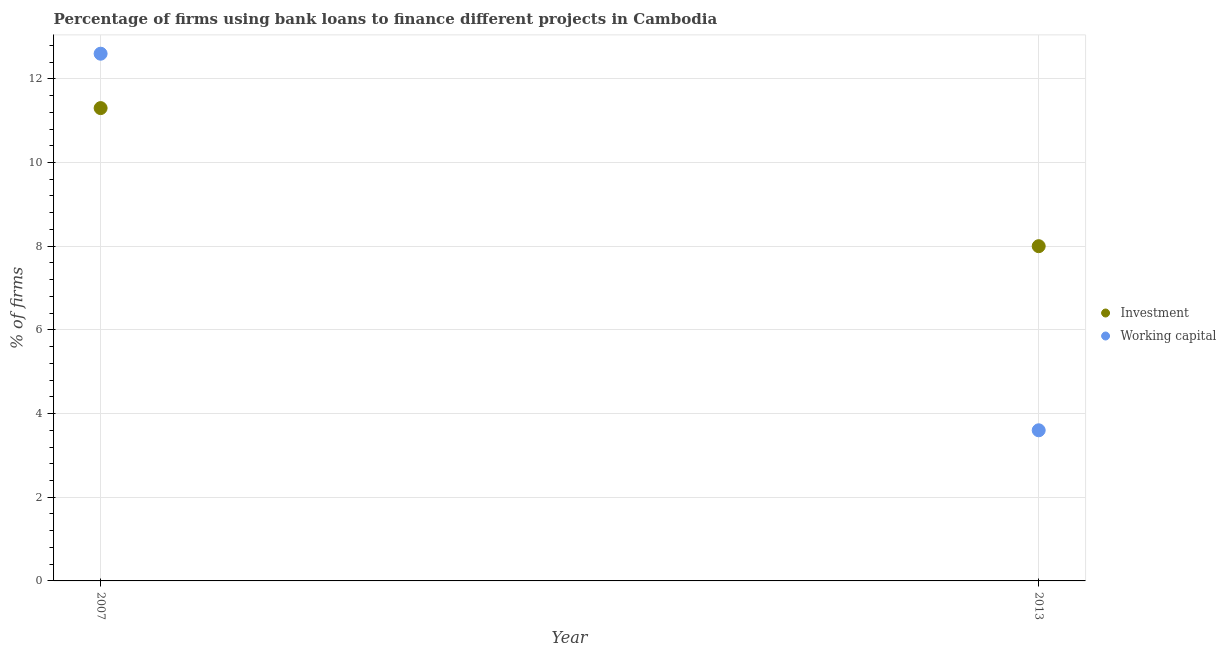How many different coloured dotlines are there?
Offer a terse response. 2. Is the number of dotlines equal to the number of legend labels?
Provide a succinct answer. Yes. In which year was the percentage of firms using banks to finance investment maximum?
Make the answer very short. 2007. What is the total percentage of firms using banks to finance working capital in the graph?
Offer a very short reply. 16.2. What is the difference between the percentage of firms using banks to finance investment in 2007 and that in 2013?
Give a very brief answer. 3.3. What is the difference between the percentage of firms using banks to finance investment in 2007 and the percentage of firms using banks to finance working capital in 2013?
Keep it short and to the point. 7.7. What is the average percentage of firms using banks to finance investment per year?
Keep it short and to the point. 9.65. In the year 2007, what is the difference between the percentage of firms using banks to finance working capital and percentage of firms using banks to finance investment?
Offer a very short reply. 1.3. What is the ratio of the percentage of firms using banks to finance working capital in 2007 to that in 2013?
Your answer should be very brief. 3.5. How many years are there in the graph?
Give a very brief answer. 2. What is the difference between two consecutive major ticks on the Y-axis?
Provide a succinct answer. 2. Are the values on the major ticks of Y-axis written in scientific E-notation?
Keep it short and to the point. No. Does the graph contain any zero values?
Offer a terse response. No. How many legend labels are there?
Offer a very short reply. 2. What is the title of the graph?
Provide a succinct answer. Percentage of firms using bank loans to finance different projects in Cambodia. What is the label or title of the X-axis?
Keep it short and to the point. Year. What is the label or title of the Y-axis?
Provide a short and direct response. % of firms. What is the % of firms in Working capital in 2007?
Keep it short and to the point. 12.6. What is the % of firms of Investment in 2013?
Ensure brevity in your answer.  8. What is the total % of firms in Investment in the graph?
Give a very brief answer. 19.3. What is the difference between the % of firms of Working capital in 2007 and that in 2013?
Offer a very short reply. 9. What is the average % of firms of Investment per year?
Give a very brief answer. 9.65. What is the average % of firms of Working capital per year?
Keep it short and to the point. 8.1. In the year 2007, what is the difference between the % of firms of Investment and % of firms of Working capital?
Offer a very short reply. -1.3. What is the ratio of the % of firms of Investment in 2007 to that in 2013?
Offer a very short reply. 1.41. What is the ratio of the % of firms in Working capital in 2007 to that in 2013?
Keep it short and to the point. 3.5. What is the difference between the highest and the second highest % of firms of Investment?
Offer a very short reply. 3.3. What is the difference between the highest and the second highest % of firms of Working capital?
Offer a very short reply. 9. What is the difference between the highest and the lowest % of firms of Investment?
Give a very brief answer. 3.3. 